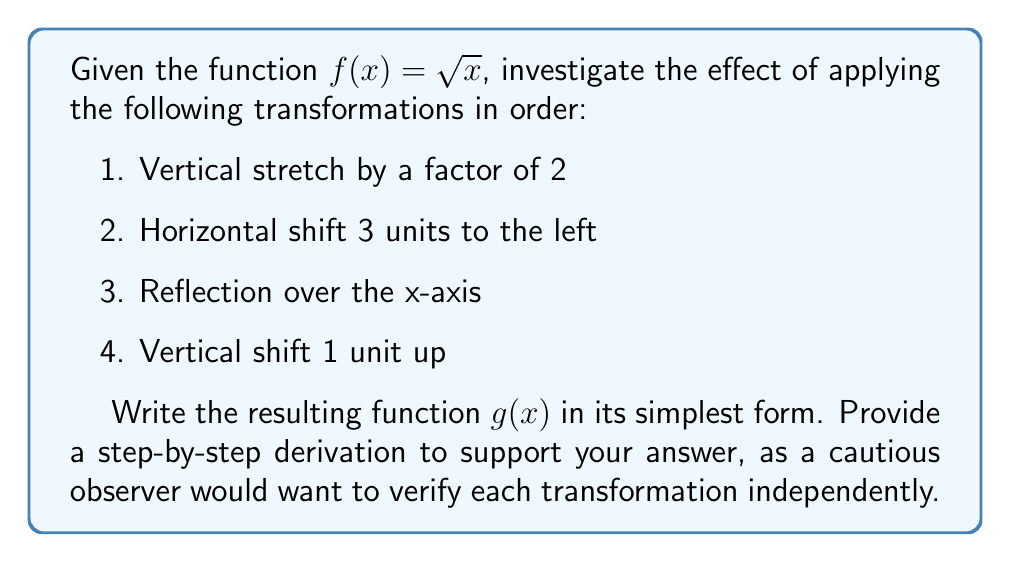Help me with this question. Let's apply each transformation step-by-step to the original function $f(x) = \sqrt{x}$:

1. Vertical stretch by a factor of 2:
   $f_1(x) = 2f(x) = 2\sqrt{x}$

2. Horizontal shift 3 units to the left:
   $f_2(x) = f_1(x+3) = 2\sqrt{x+3}$

3. Reflection over the x-axis:
   $f_3(x) = -f_2(x) = -2\sqrt{x+3}$

4. Vertical shift 1 unit up:
   $g(x) = f_3(x) + 1 = -2\sqrt{x+3} + 1$

To verify each step:
- The vertical stretch doubles the output for any given input.
- The horizontal shift replaces x with (x+3) inside the square root.
- The reflection changes the sign of the entire expression.
- The vertical shift adds 1 to the final result.

Therefore, the resulting function $g(x)$ after applying all transformations is:

$$g(x) = -2\sqrt{x+3} + 1$$

This form cannot be simplified further while maintaining the square root notation.
Answer: $g(x) = -2\sqrt{x+3} + 1$ 